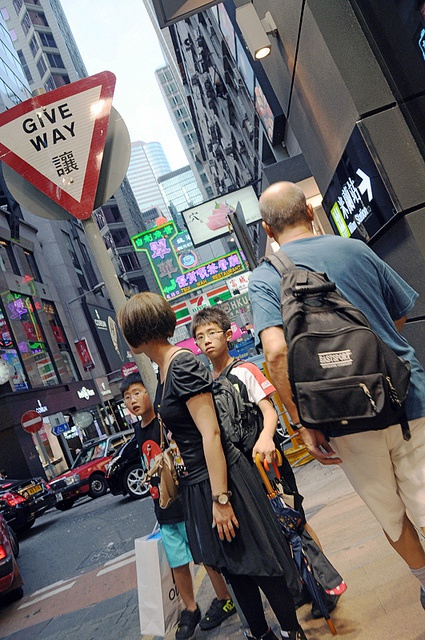Describe the objects in this image and their specific colors. I can see people in darkgray, tan, black, and gray tones, people in darkgray, black, tan, and gray tones, backpack in darkgray, black, and gray tones, people in darkgray, black, maroon, and teal tones, and people in darkgray, black, tan, and white tones in this image. 